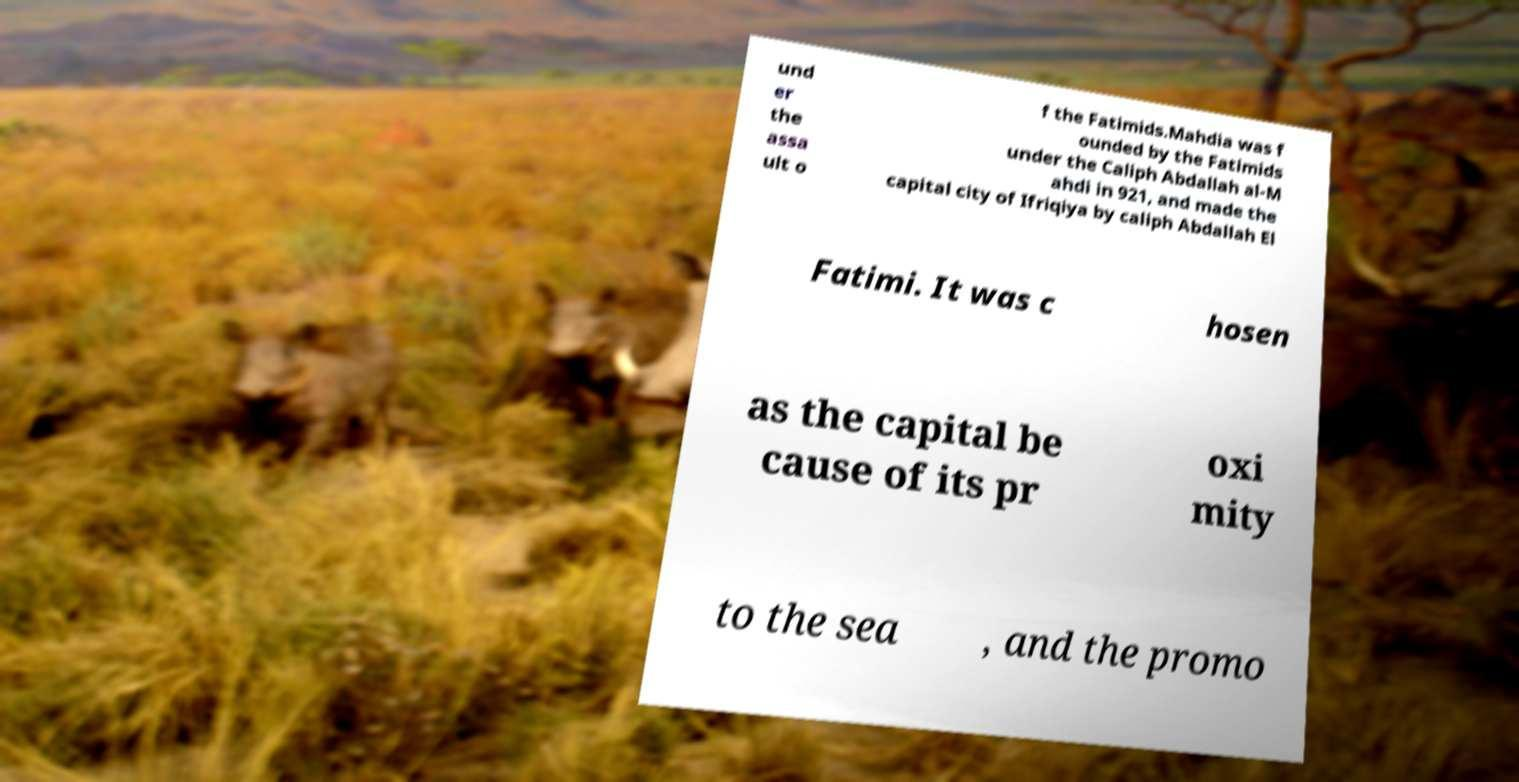Can you read and provide the text displayed in the image?This photo seems to have some interesting text. Can you extract and type it out for me? und er the assa ult o f the Fatimids.Mahdia was f ounded by the Fatimids under the Caliph Abdallah al-M ahdi in 921, and made the capital city of Ifriqiya by caliph Abdallah El Fatimi. It was c hosen as the capital be cause of its pr oxi mity to the sea , and the promo 